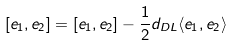<formula> <loc_0><loc_0><loc_500><loc_500>[ e _ { 1 } , e _ { 2 } ] = [ e _ { 1 } , e _ { 2 } ] - \frac { 1 } { 2 } d _ { D L } \langle e _ { 1 } , e _ { 2 } \rangle</formula> 